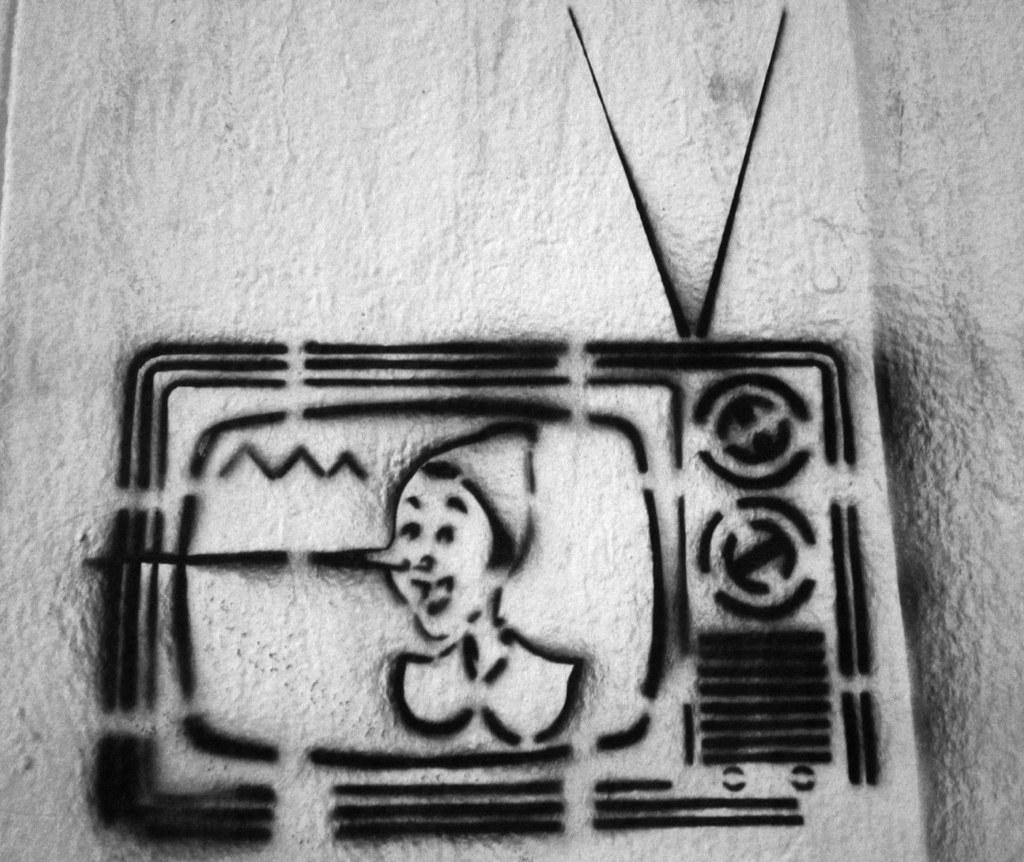What type of drawings can be seen on the wall in the image? There is a drawing of a television and a drawing of a person on the wall. Can you describe the content of the drawings? One drawing depicts a television, while the other drawing depicts a person. How many ducks are visible in the wilderness in the image? There are no ducks or wilderness present in the image; it features drawings of a television and a person on the wall. 